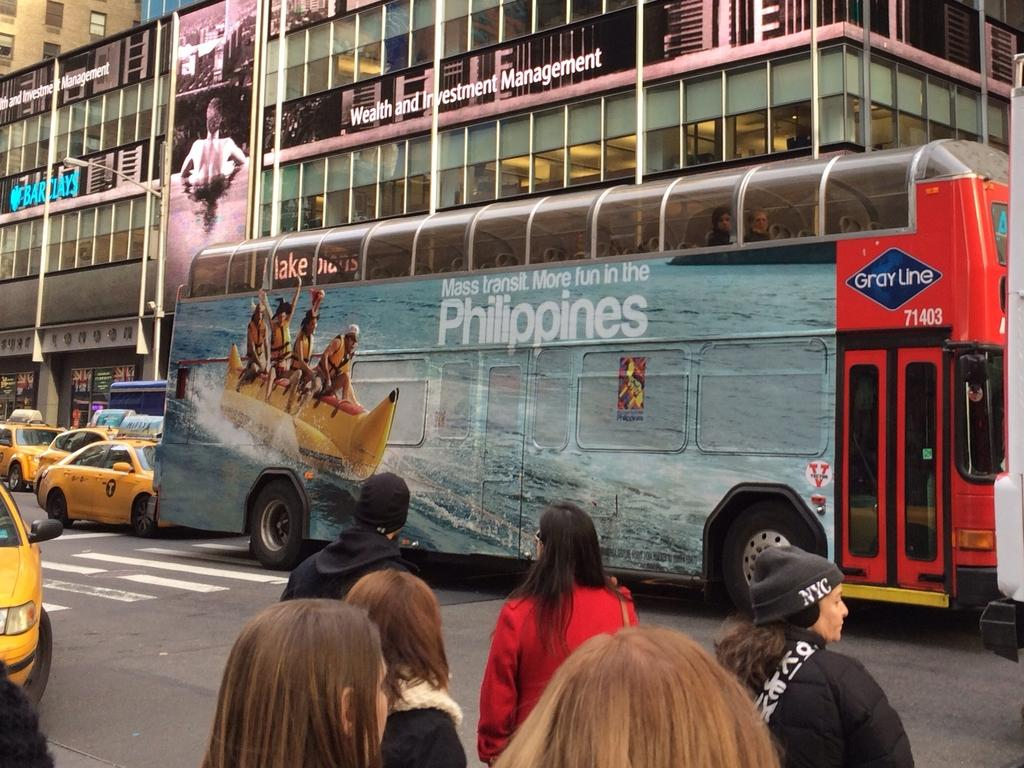<image>
Render a clear and concise summary of the photo. A bus has an advertisement for the Philippines on its side. 